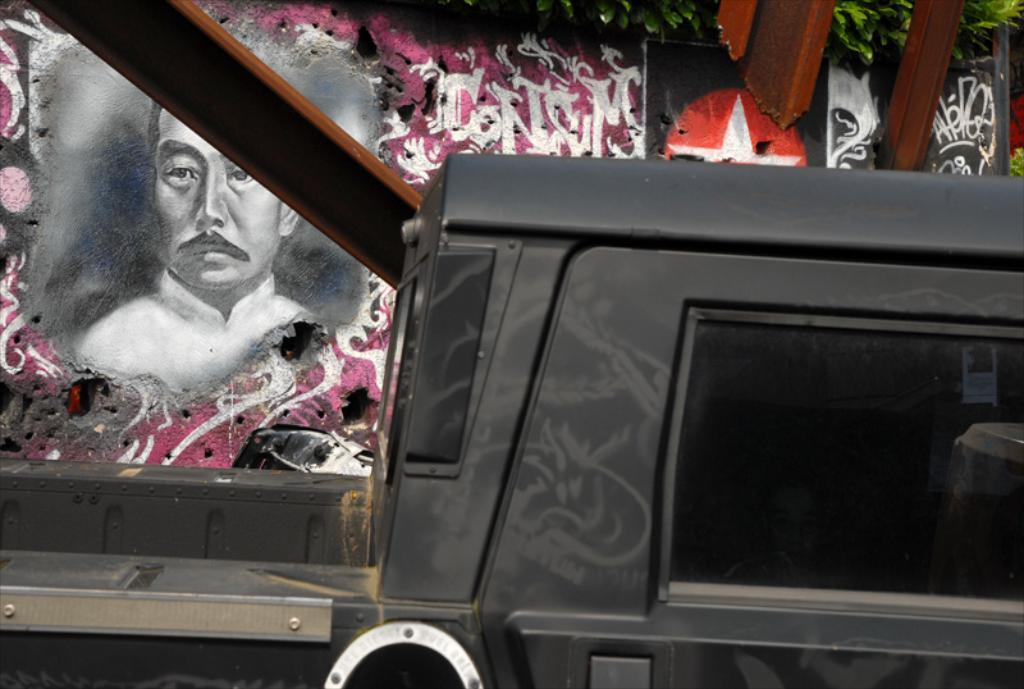What type of motor vehicle is in the image? The specific type of motor vehicle is not mentioned, but it is present in the image. Where is the motor vehicle located in the image? The motor vehicle is on the road in the image. What can be seen on the wall in the image? There are paintings on the wall in the image. What type of force is being applied to the heart in the image? There is no mention of a heart or any force being applied in the image. 